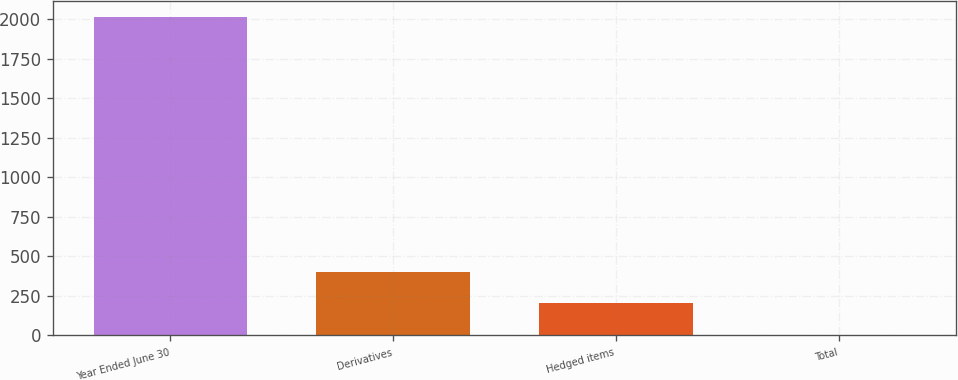<chart> <loc_0><loc_0><loc_500><loc_500><bar_chart><fcel>Year Ended June 30<fcel>Derivatives<fcel>Hedged items<fcel>Total<nl><fcel>2013<fcel>403.4<fcel>202.2<fcel>1<nl></chart> 